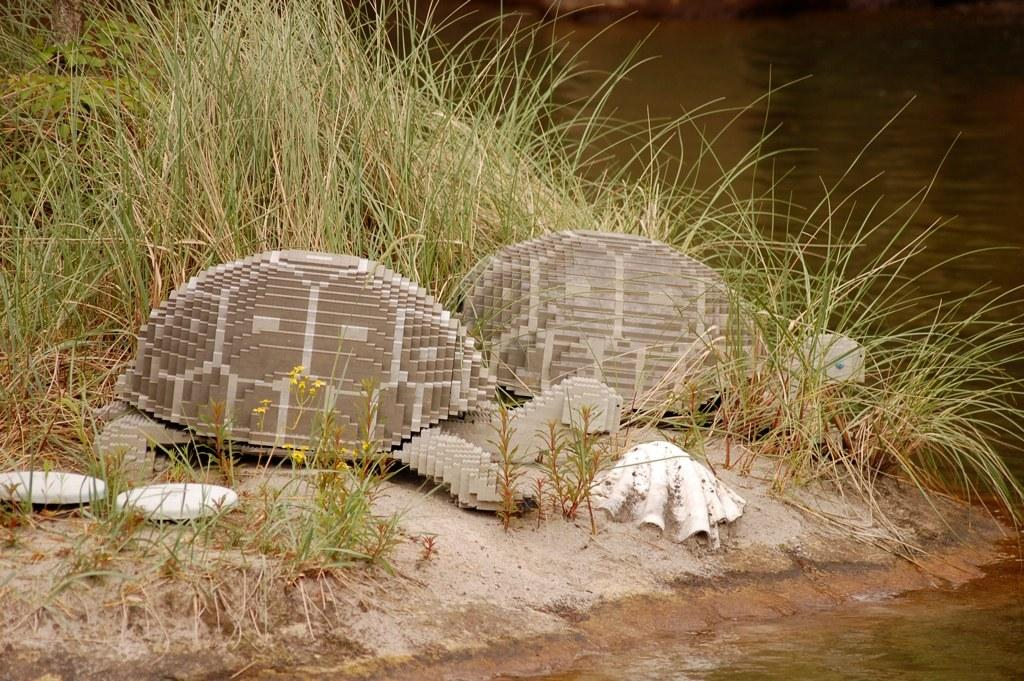What type of vegetation can be seen in the image? There is grass in the image. What other objects can be seen in the image? There are shells and tortoise toys in the image. Are there any objects on the ground in the image? Yes, there are objects on the ground in the image. What can be seen in the background of the image? There is water visible in the background of the image. Where is the faucet located in the image? There is no faucet present in the image. Can you see any pigs in the image? There are no pigs present in the image. 